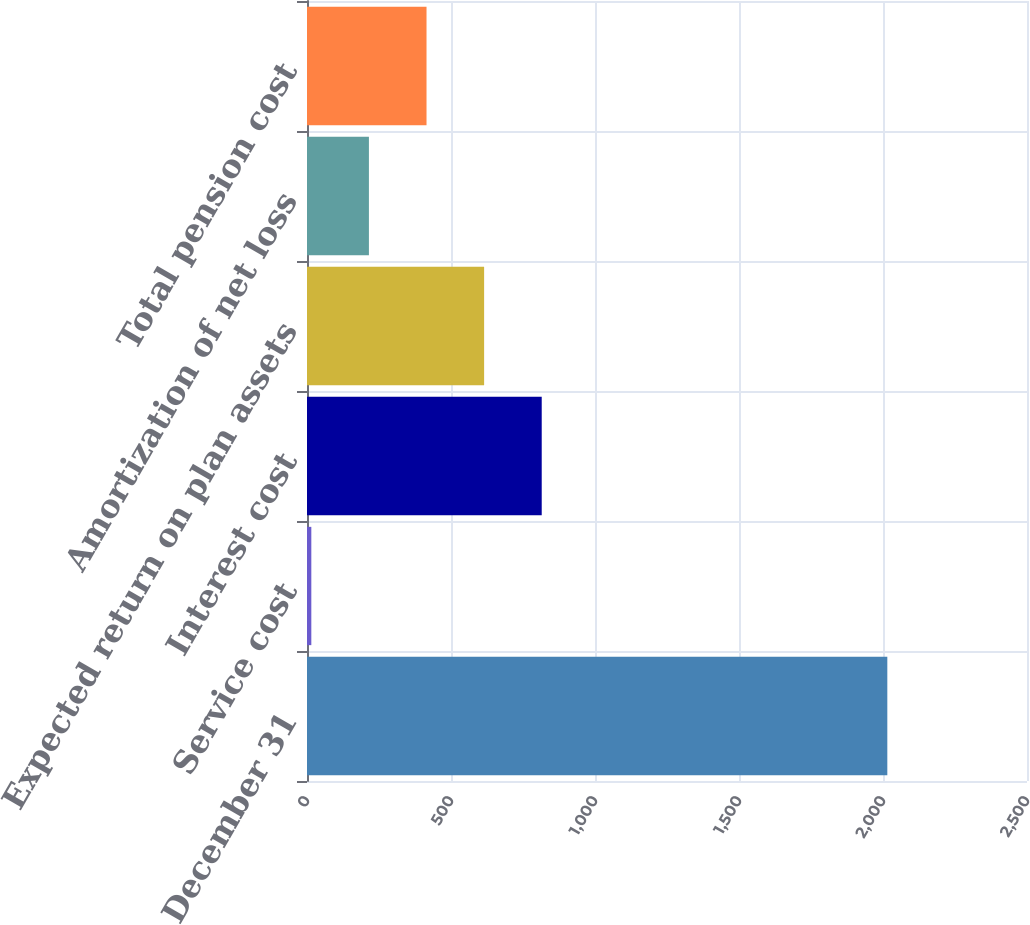Convert chart. <chart><loc_0><loc_0><loc_500><loc_500><bar_chart><fcel>December 31<fcel>Service cost<fcel>Interest cost<fcel>Expected return on plan assets<fcel>Amortization of net loss<fcel>Total pension cost<nl><fcel>2015<fcel>15<fcel>815<fcel>615<fcel>215<fcel>415<nl></chart> 